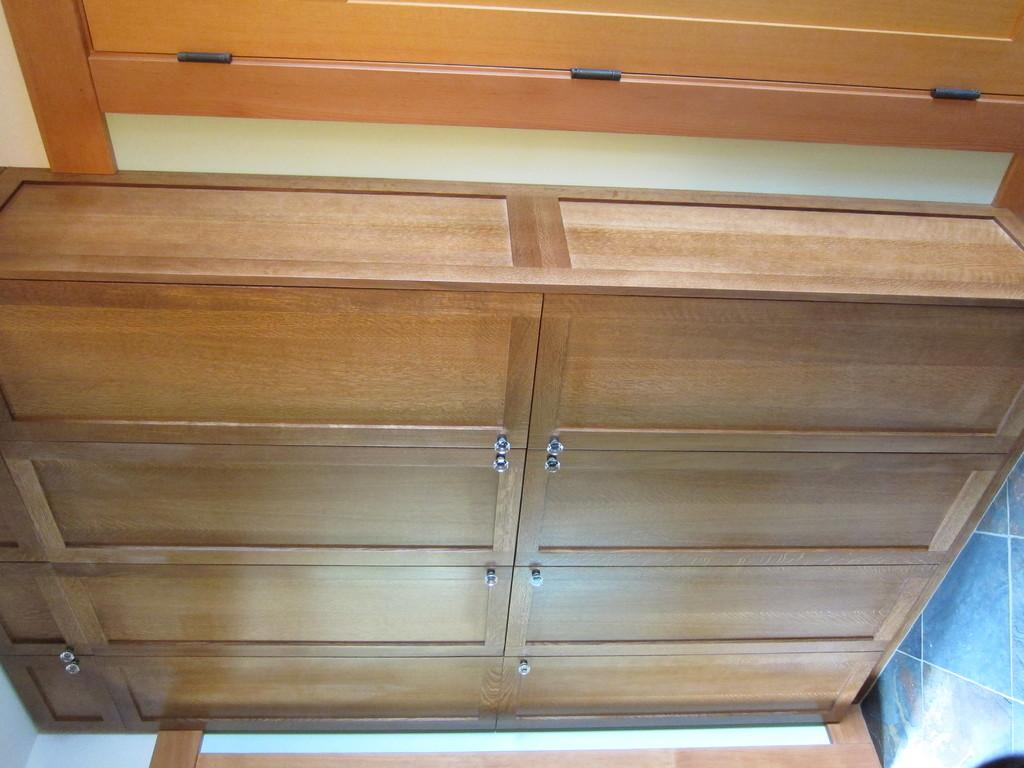What type of furniture is present in the image? There is a desk in the image. What is located on the desk? There is a wooden object on the desk. What type of cast can be seen in the image? There is no cast present in the image. What is the connection between the wooden object and the sea in the image? There is no sea or any reference to the sea in the image. 